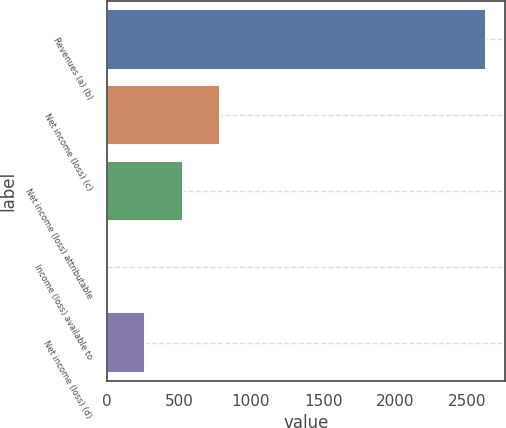<chart> <loc_0><loc_0><loc_500><loc_500><bar_chart><fcel>Revenues (a) (b)<fcel>Net income (loss) (c)<fcel>Net income (loss) attributable<fcel>Income (loss) available to<fcel>Net income (loss) (d)<nl><fcel>2627<fcel>788.2<fcel>525.52<fcel>0.16<fcel>262.84<nl></chart> 